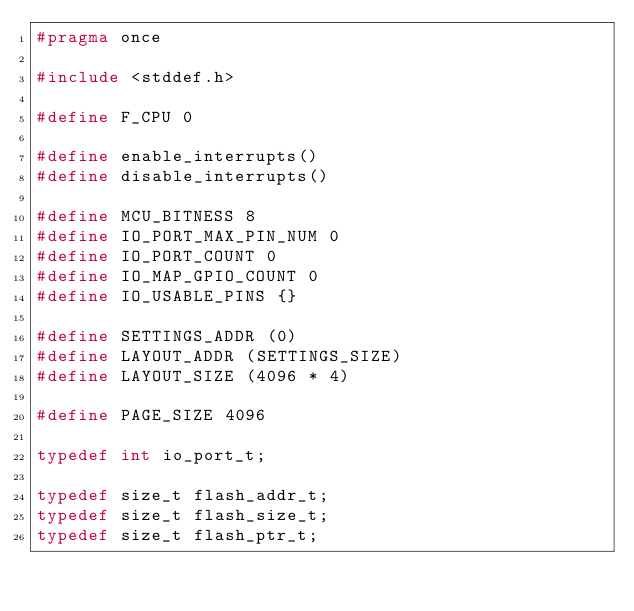Convert code to text. <code><loc_0><loc_0><loc_500><loc_500><_C_>#pragma once

#include <stddef.h>

#define F_CPU 0

#define enable_interrupts()
#define disable_interrupts()

#define MCU_BITNESS 8
#define IO_PORT_MAX_PIN_NUM 0
#define IO_PORT_COUNT 0
#define IO_MAP_GPIO_COUNT 0
#define IO_USABLE_PINS {}

#define SETTINGS_ADDR (0)
#define LAYOUT_ADDR (SETTINGS_SIZE)
#define LAYOUT_SIZE (4096 * 4)

#define PAGE_SIZE 4096

typedef int io_port_t;

typedef size_t flash_addr_t;
typedef size_t flash_size_t;
typedef size_t flash_ptr_t;
</code> 